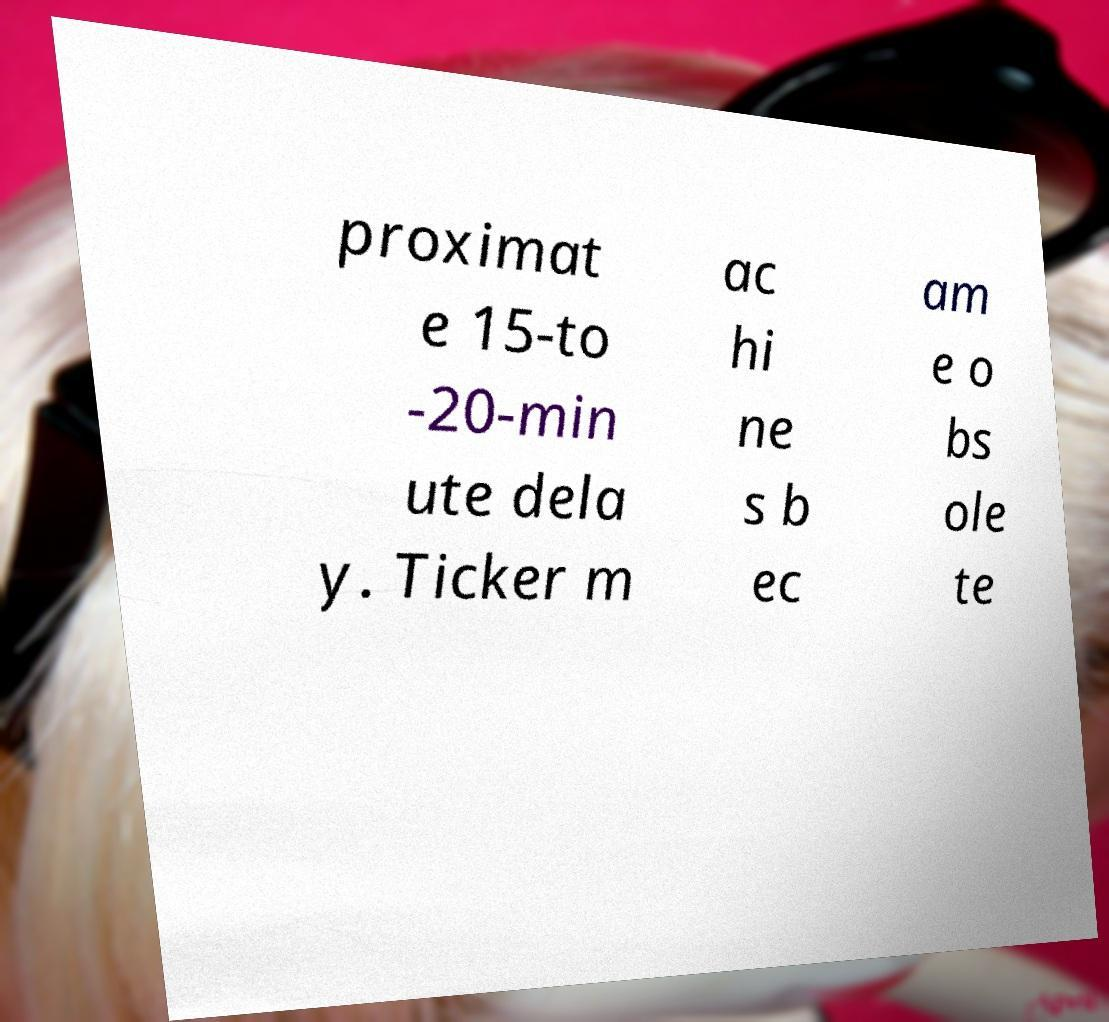Please identify and transcribe the text found in this image. proximat e 15-to -20-min ute dela y. Ticker m ac hi ne s b ec am e o bs ole te 